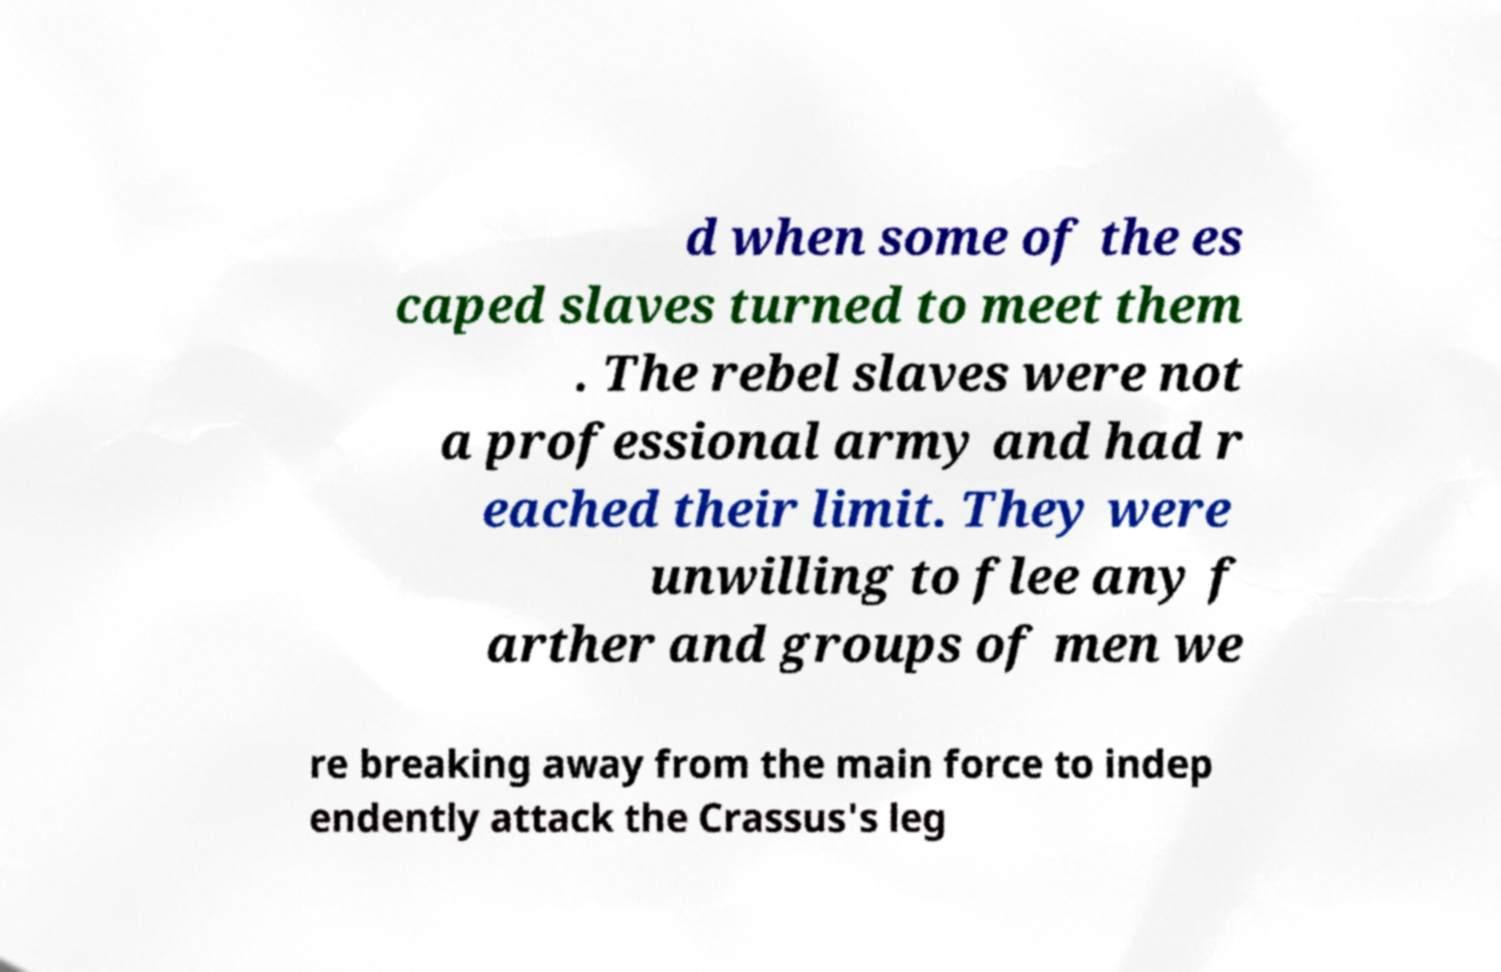Can you accurately transcribe the text from the provided image for me? d when some of the es caped slaves turned to meet them . The rebel slaves were not a professional army and had r eached their limit. They were unwilling to flee any f arther and groups of men we re breaking away from the main force to indep endently attack the Crassus's leg 